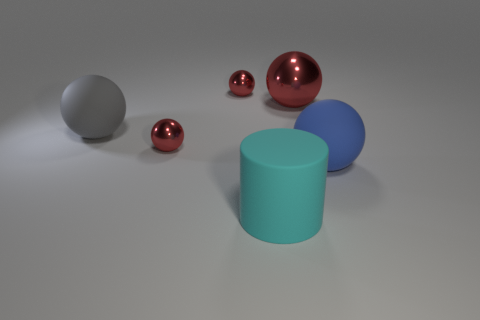There is a tiny red sphere behind the big object that is on the left side of the large cylinder; what is it made of?
Your answer should be compact. Metal. There is a large shiny object; are there any small red balls in front of it?
Offer a very short reply. Yes. Is the number of matte cylinders that are left of the cyan cylinder greater than the number of large cyan rubber things?
Your response must be concise. No. Is there a small object of the same color as the rubber cylinder?
Offer a terse response. No. What is the color of the matte cylinder that is the same size as the gray thing?
Your answer should be compact. Cyan. Are there any cyan things in front of the red object that is in front of the gray matte object?
Make the answer very short. Yes. There is a large red thing that is on the right side of the large gray rubber sphere; what material is it?
Keep it short and to the point. Metal. Are the big object that is in front of the big blue matte sphere and the large gray thing that is behind the large blue sphere made of the same material?
Make the answer very short. Yes. Are there the same number of cyan cylinders that are behind the big metal thing and matte spheres that are in front of the gray matte sphere?
Keep it short and to the point. No. What number of large spheres have the same material as the gray object?
Your answer should be very brief. 1. 